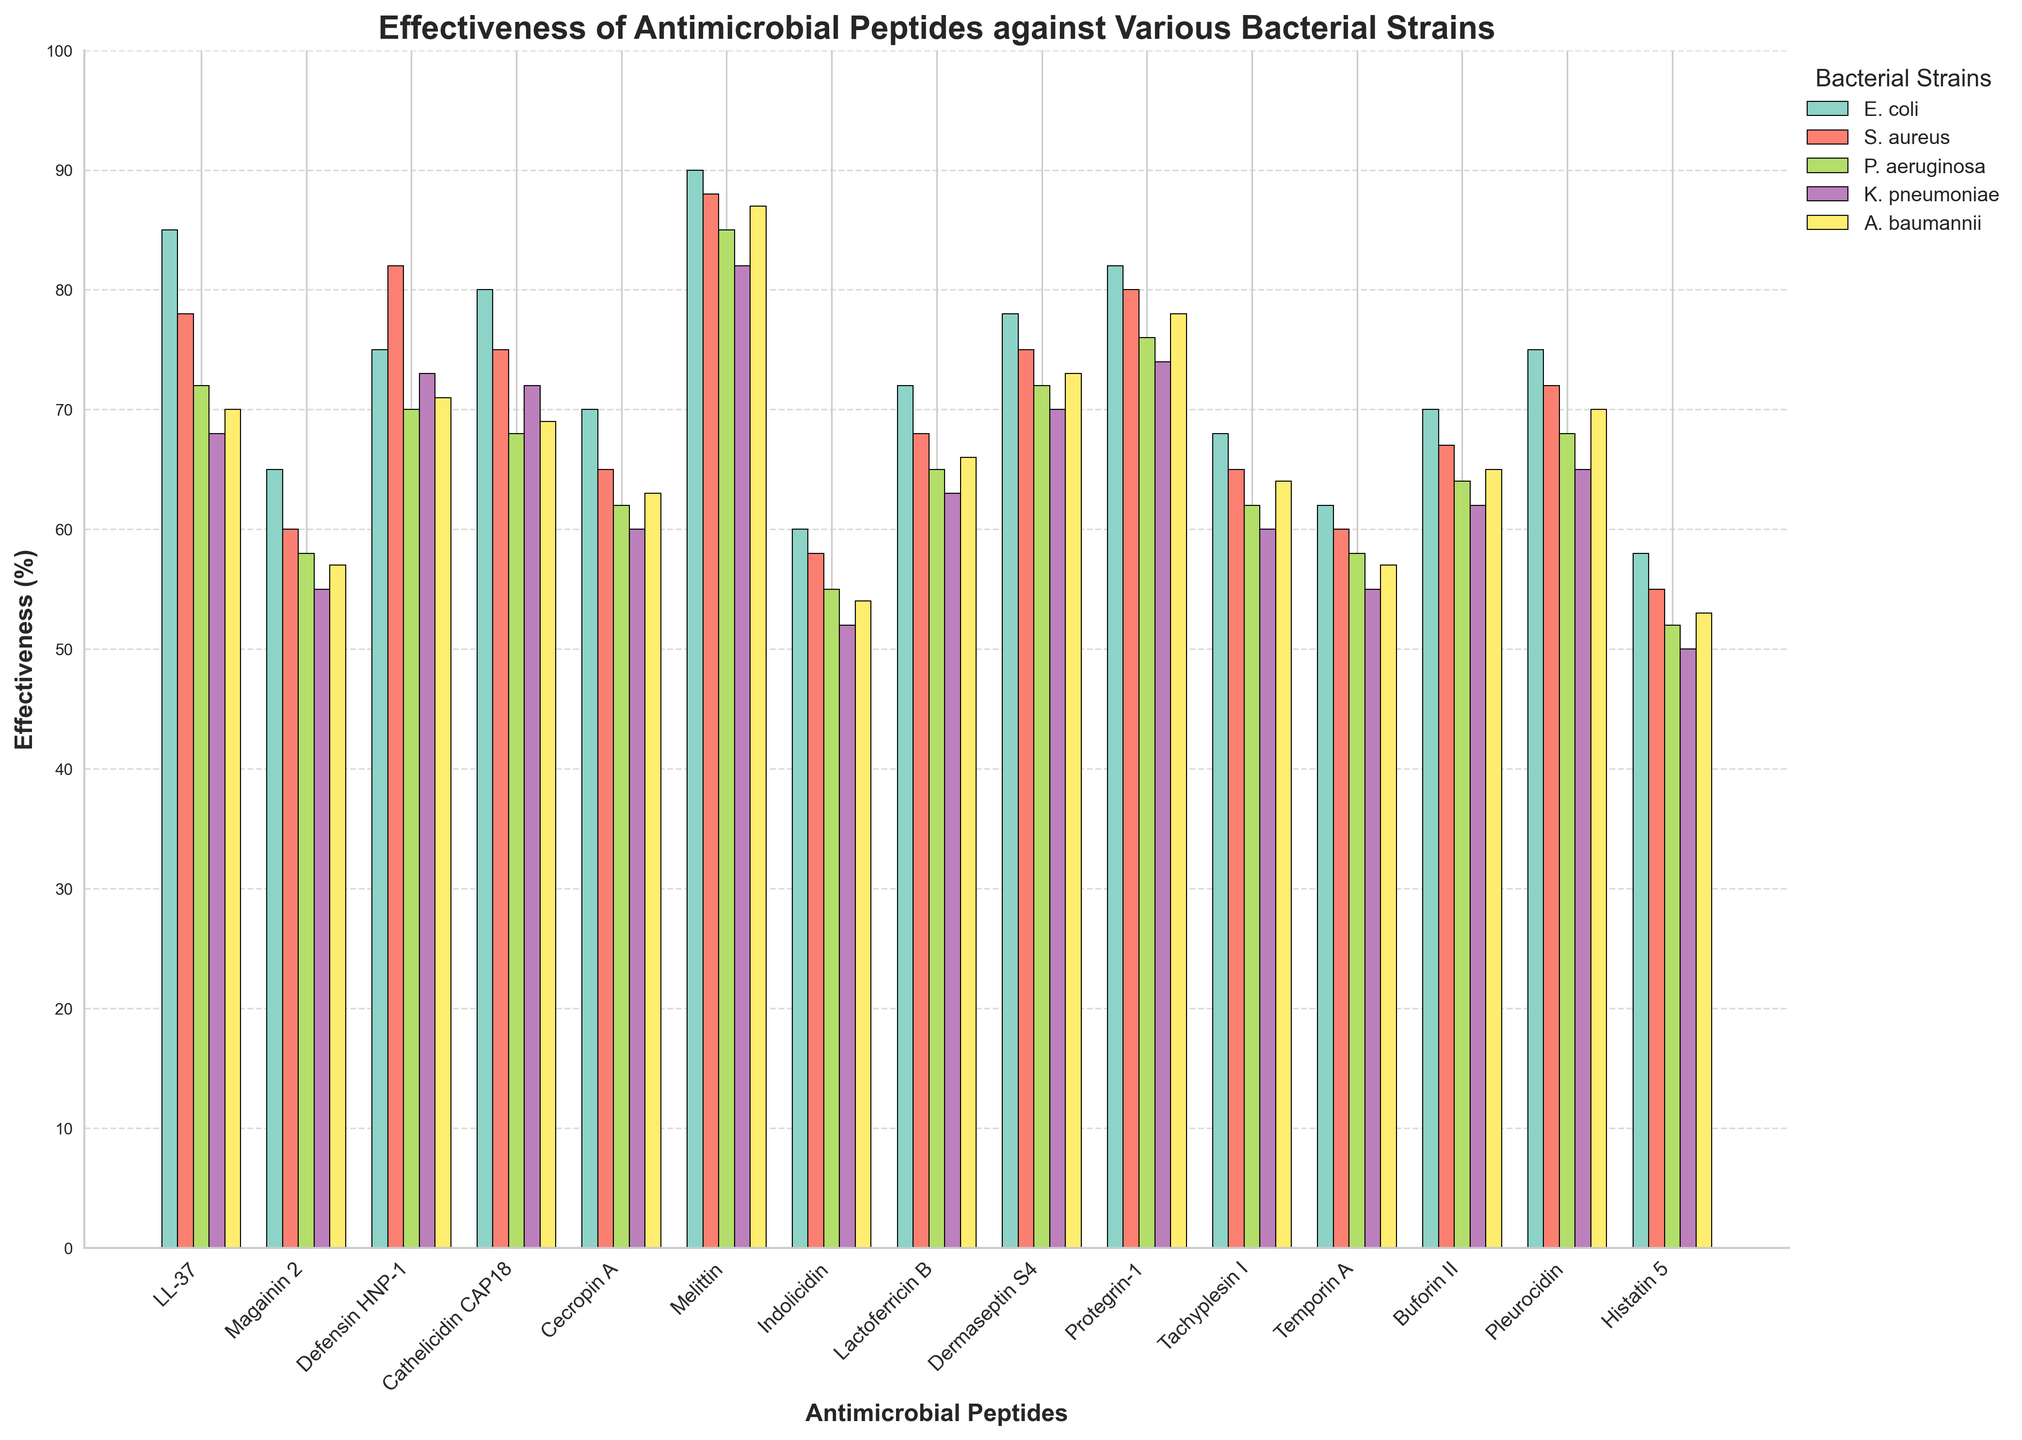Which peptide is the most effective against E. coli? By checking the bar heights for E. coli, Melittin has the tallest bar, indicating its highest effectiveness against E. coli.
Answer: Melittin Which bacterial strain has the lowest effectiveness for LL-37? For LL-37, compare the bar heights for all bacterial strains. The bar for K. pneumoniae is the shortest.
Answer: K. pneumoniae What is the average effectiveness of Cathelicidin CAP18 across all bacterial strains? Sum the effectiveness values for Cathelicidin CAP18 (80, 75, 68, 72, 69) and divide by the number of bacterial strains (5). The sum is 364, and the average is 364/5 = 72.8.
Answer: 72.8 Which peptide shows the least variation in effectiveness across different bacterial strains? Calculate the range (maximum - minimum values) for each peptide. Buforin II has a range of 70-62=8, which is the smallest variation.
Answer: Buforin II How does the effectiveness of Magainin 2 against P. aeruginosa compare to Indolicidin against the same strain? Check the bar heights of Magainin 2 and Indolicidin against P. aeruginosa. Magainin 2 has a higher bar (58) compared to Indolicidin (55).
Answer: Magainin 2 is more effective What is the sum of the effectiveness of Protegrin-1 and Tachyplesin I against A. baumannii? Add the effectiveness values of Protegrin-1 (78) and Tachyplesin I (64) against A. baumannii. The sum is 78 + 64 = 142.
Answer: 142 Which antimicrobial peptide has the highest overall average effectiveness across all bacterial strains? Calculate the average effectiveness for each peptide and compare. Melittin has the highest averages (90+88+85+82+87)/5 = 86.4.
Answer: Melittin Which two peptides have the most similar effectiveness against S. aureus? Compare the effectiveness numbers for all peptides against S. aureus, Buforin II (67) and Lactoferricin B (68) are the closest with a difference of just 1.
Answer: Buforin II and Lactoferricin B What is the difference in effectiveness between LL-37 and Melittin against P. aeruginosa? Subtract the effectiveness of LL-37 (72) from Melittin (85) against P. aeruginosa. The difference is 85 - 72 = 13.
Answer: 13 Which peptide has uniformly high effectiveness (above 70%) against all listed bacterial strains? Check each peptide's values to see if all are above 70%. Melittin, Protegrin-1, and LL-37 all satisfy this with values above 70% for each strain.
Answer: Melittin, Protegrin-1, LL-37 